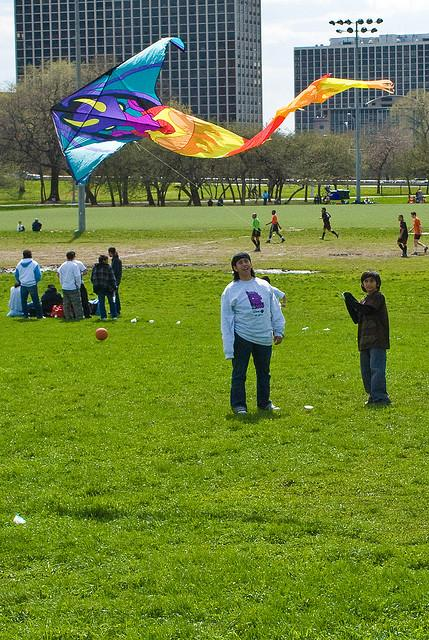The object in the air is in the shape of what animal? dragon 